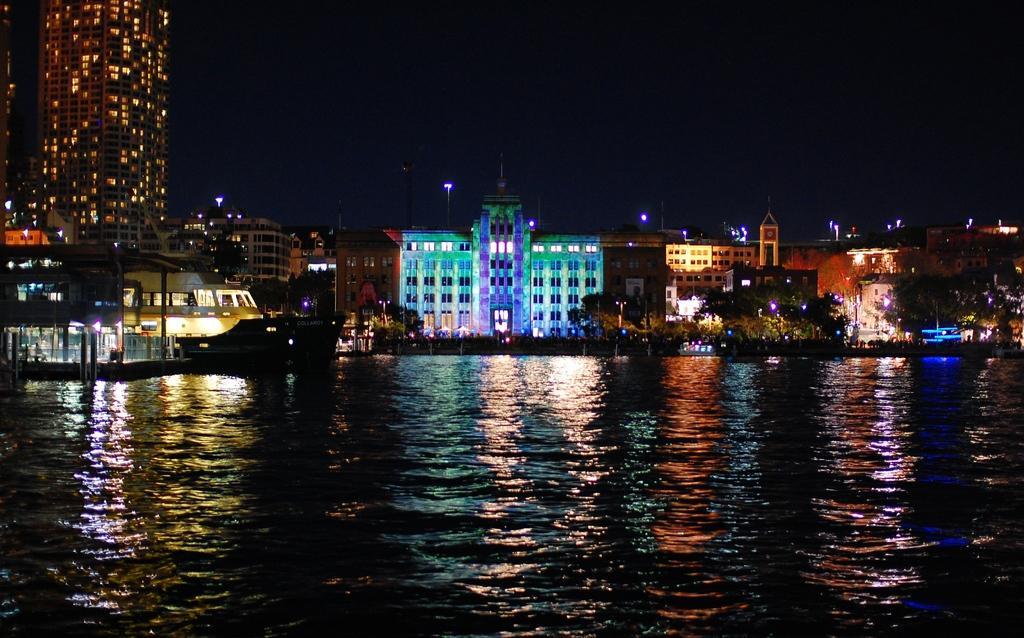Please provide a concise description of this image. In this image we can see buildings, trees and lights. At the bottom of the image, we can see water. On the left side of the image, we can see a boat on the surface of water. 